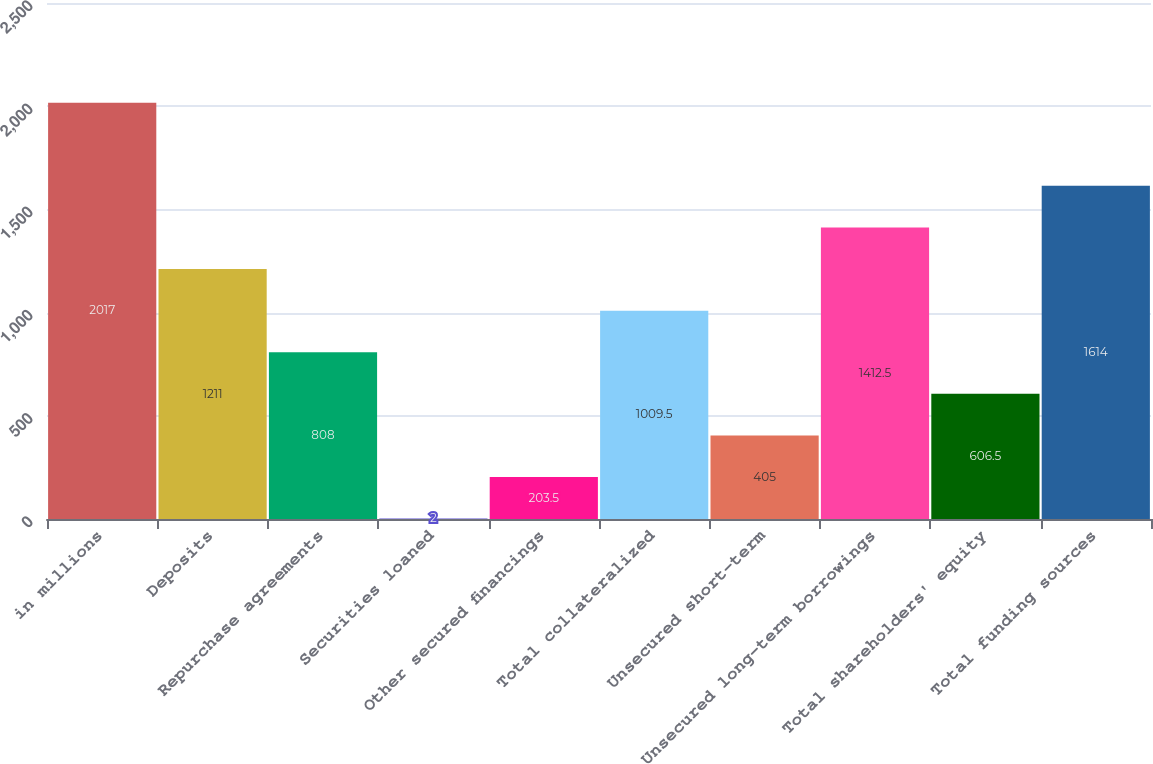Convert chart to OTSL. <chart><loc_0><loc_0><loc_500><loc_500><bar_chart><fcel>in millions<fcel>Deposits<fcel>Repurchase agreements<fcel>Securities loaned<fcel>Other secured financings<fcel>Total collateralized<fcel>Unsecured short-term<fcel>Unsecured long-term borrowings<fcel>Total shareholders' equity<fcel>Total funding sources<nl><fcel>2017<fcel>1211<fcel>808<fcel>2<fcel>203.5<fcel>1009.5<fcel>405<fcel>1412.5<fcel>606.5<fcel>1614<nl></chart> 